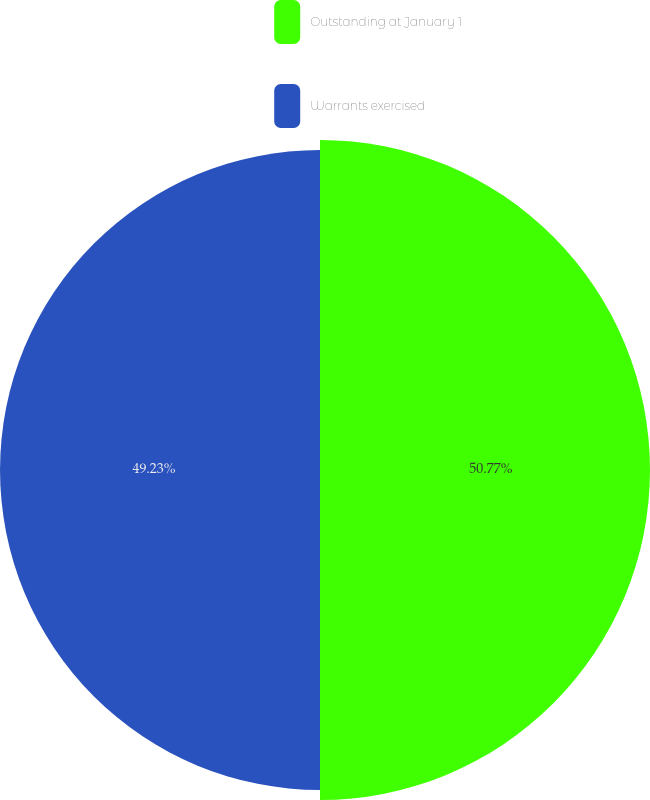Convert chart to OTSL. <chart><loc_0><loc_0><loc_500><loc_500><pie_chart><fcel>Outstanding at January 1<fcel>Warrants exercised<nl><fcel>50.77%<fcel>49.23%<nl></chart> 